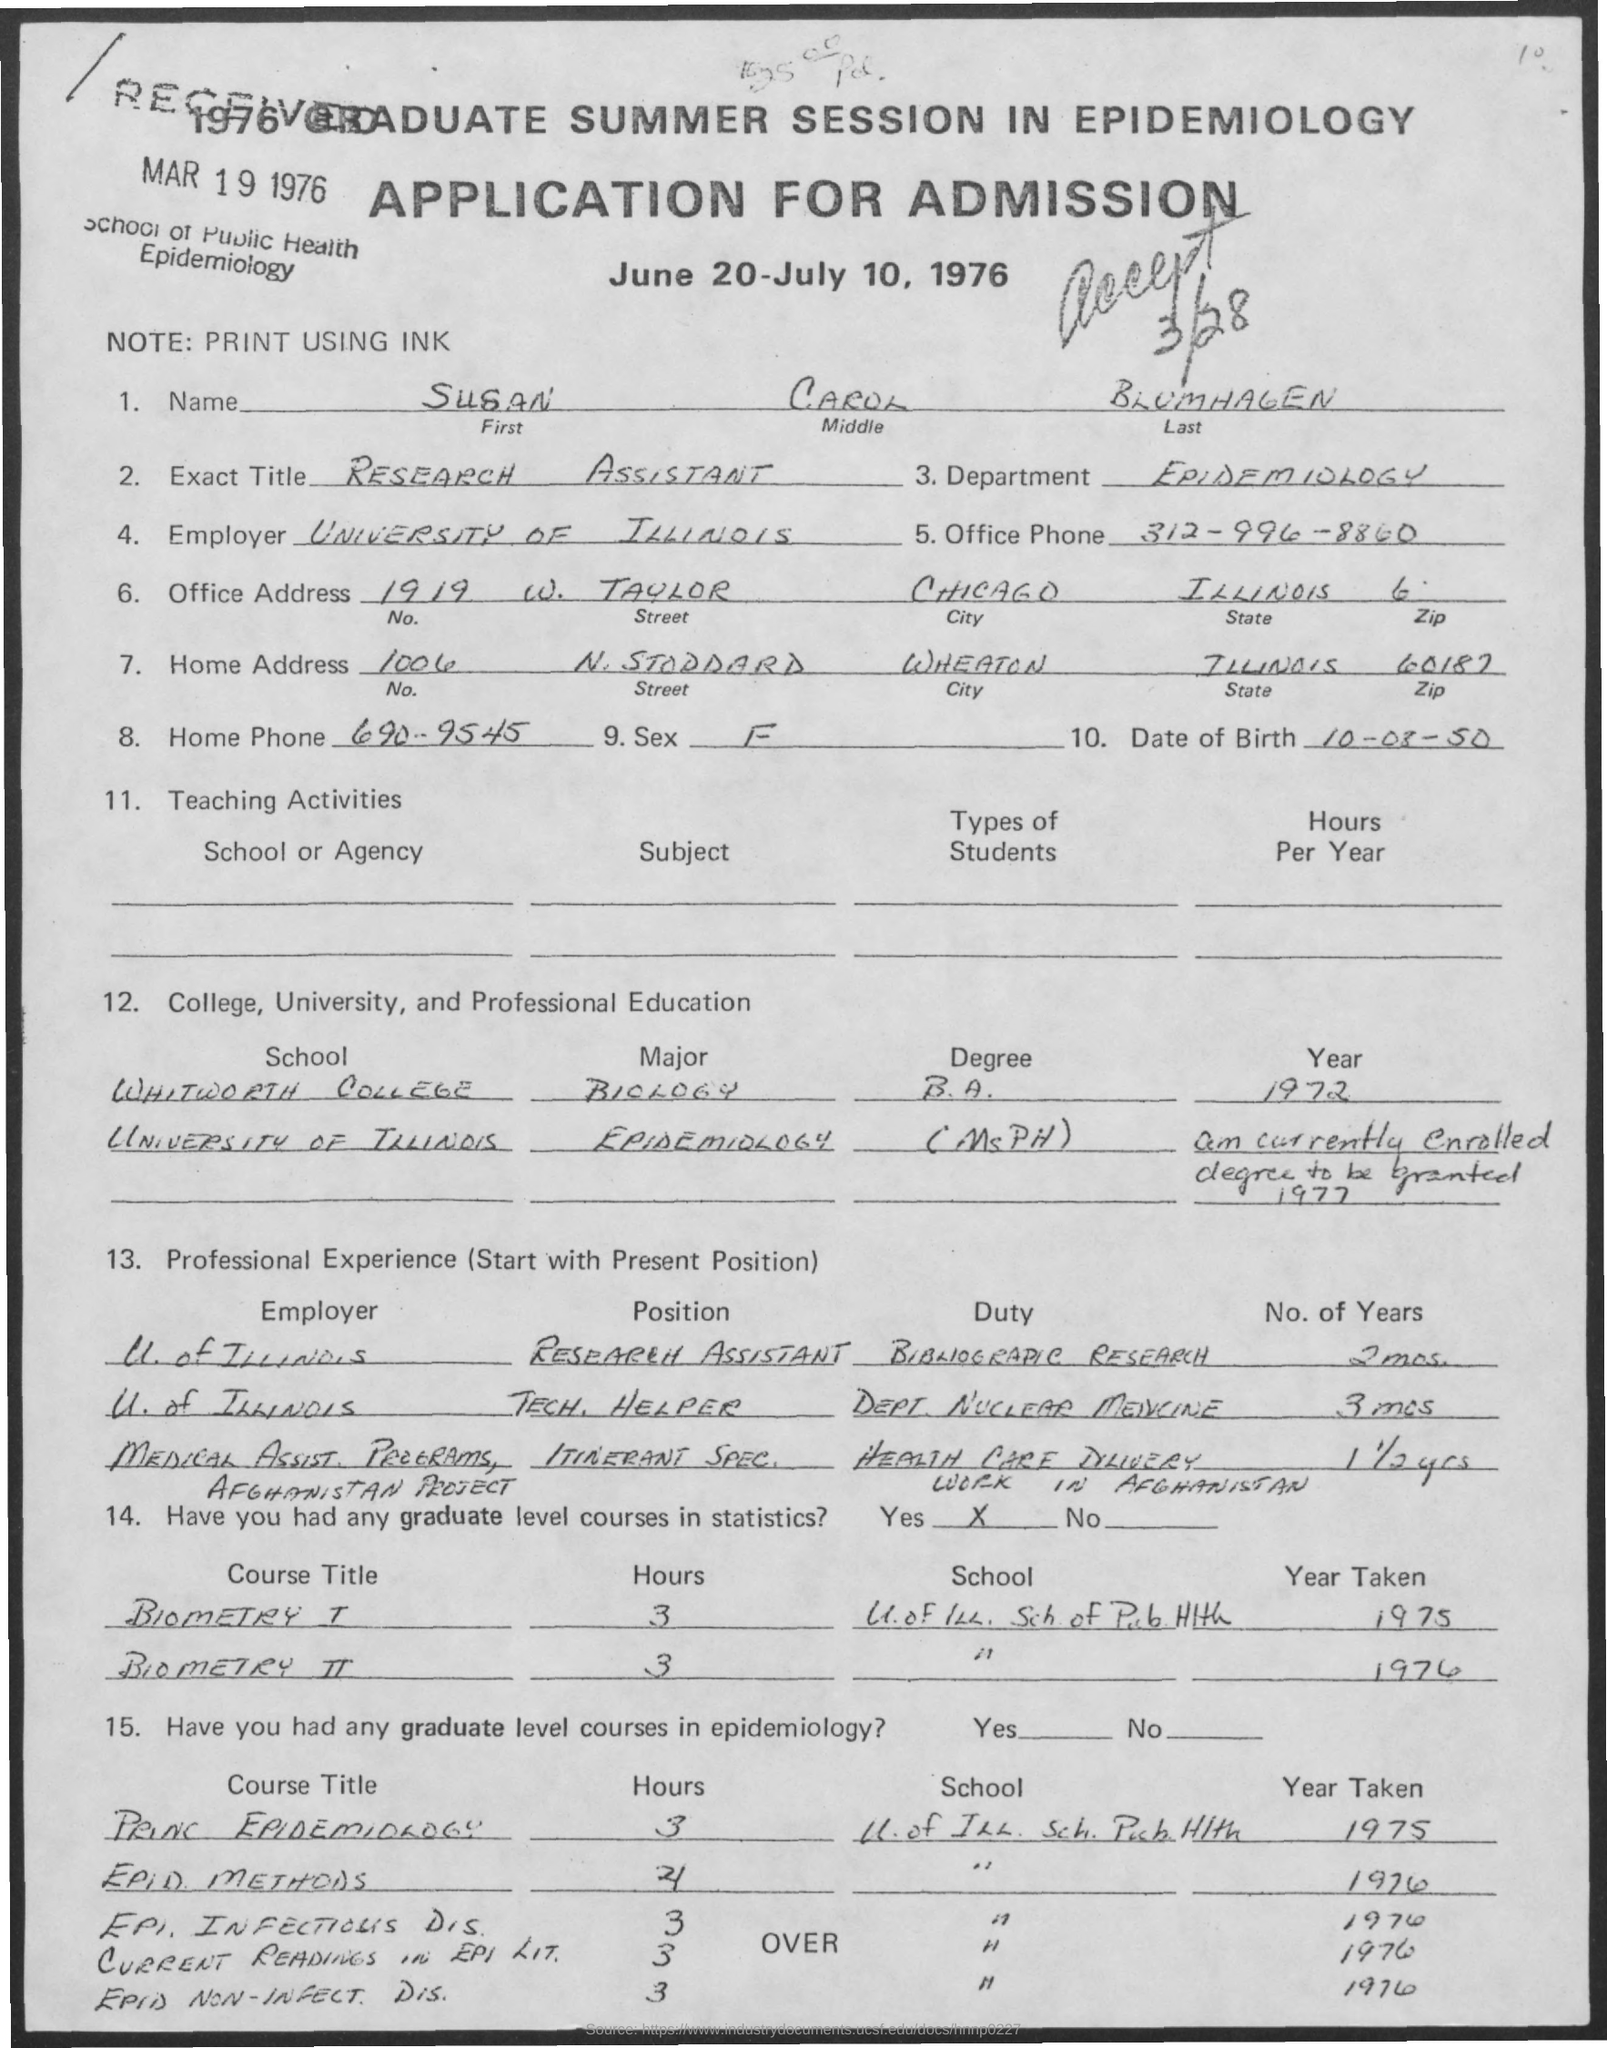What is the name of the department mentioned in the given application ?
Provide a short and direct response. Epidemiology. What is the first name mentioned in the given application ?
Offer a terse response. Susan. What is the middle name as mentioned in the given application ?
Ensure brevity in your answer.  Carol. What is the exact title mentioned in the given application ?
Give a very brief answer. Research assistant. What is the home phone number mentioned in the given application ?
Your response must be concise. 690-9545. What is the name of the city mentioned in the office address ?
Offer a terse response. Chicago. What is the note mentioned in the given application ?
Offer a very short reply. Print using ink. What is the sex mentioned in the given application ?
Offer a terse response. F. 